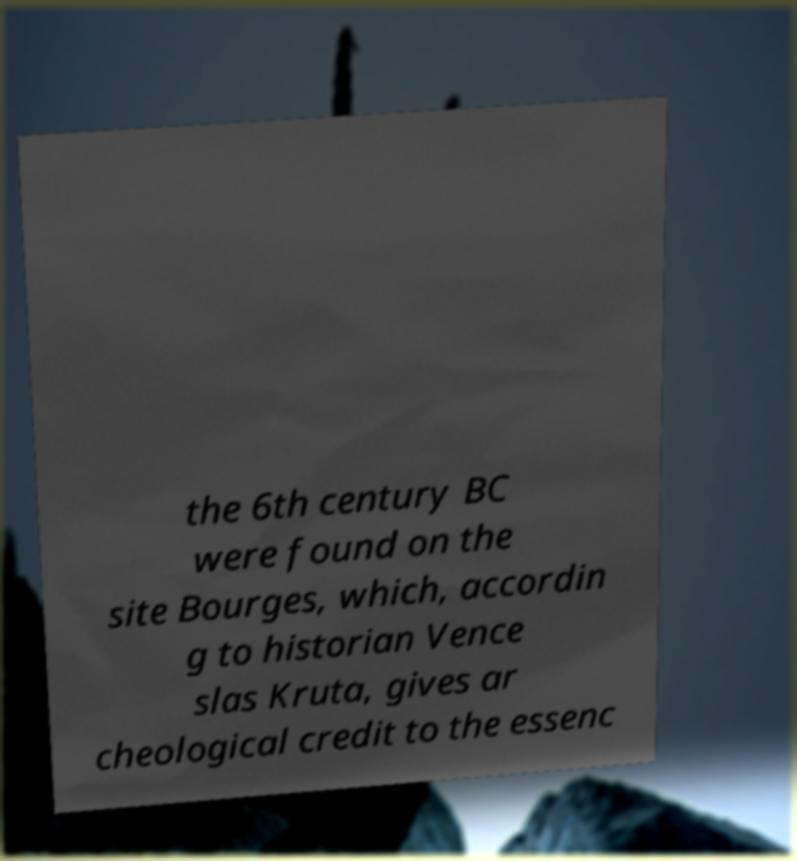Please read and relay the text visible in this image. What does it say? the 6th century BC were found on the site Bourges, which, accordin g to historian Vence slas Kruta, gives ar cheological credit to the essenc 